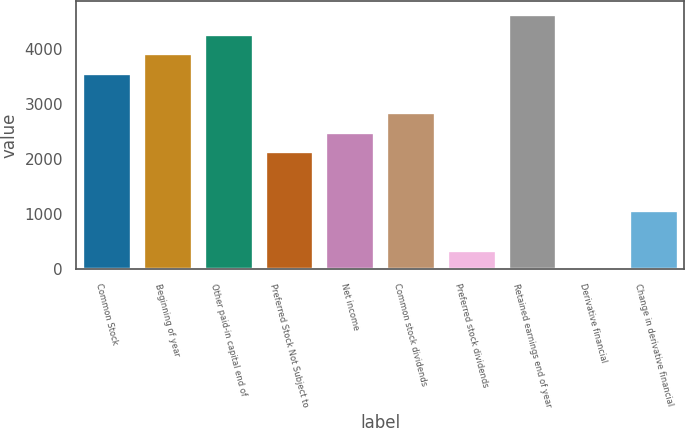<chart> <loc_0><loc_0><loc_500><loc_500><bar_chart><fcel>Common Stock<fcel>Beginning of year<fcel>Other paid-in capital end of<fcel>Preferred Stock Not Subject to<fcel>Net income<fcel>Common stock dividends<fcel>Preferred stock dividends<fcel>Retained earnings end of year<fcel>Derivative financial<fcel>Change in derivative financial<nl><fcel>3562<fcel>3917.9<fcel>4273.8<fcel>2138.4<fcel>2494.3<fcel>2850.2<fcel>358.9<fcel>4629.7<fcel>3<fcel>1070.7<nl></chart> 